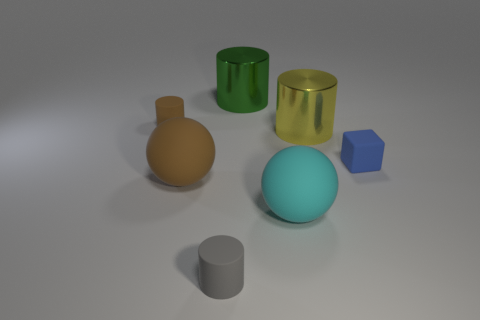Subtract all small brown cylinders. How many cylinders are left? 3 Subtract all cyan spheres. How many spheres are left? 1 Subtract all balls. How many objects are left? 5 Subtract all red cylinders. How many cyan balls are left? 1 Subtract all small cyan shiny objects. Subtract all small cylinders. How many objects are left? 5 Add 7 tiny cylinders. How many tiny cylinders are left? 9 Add 7 big cyan matte objects. How many big cyan matte objects exist? 8 Add 3 tiny cylinders. How many objects exist? 10 Subtract 0 green cubes. How many objects are left? 7 Subtract all green cylinders. Subtract all red blocks. How many cylinders are left? 3 